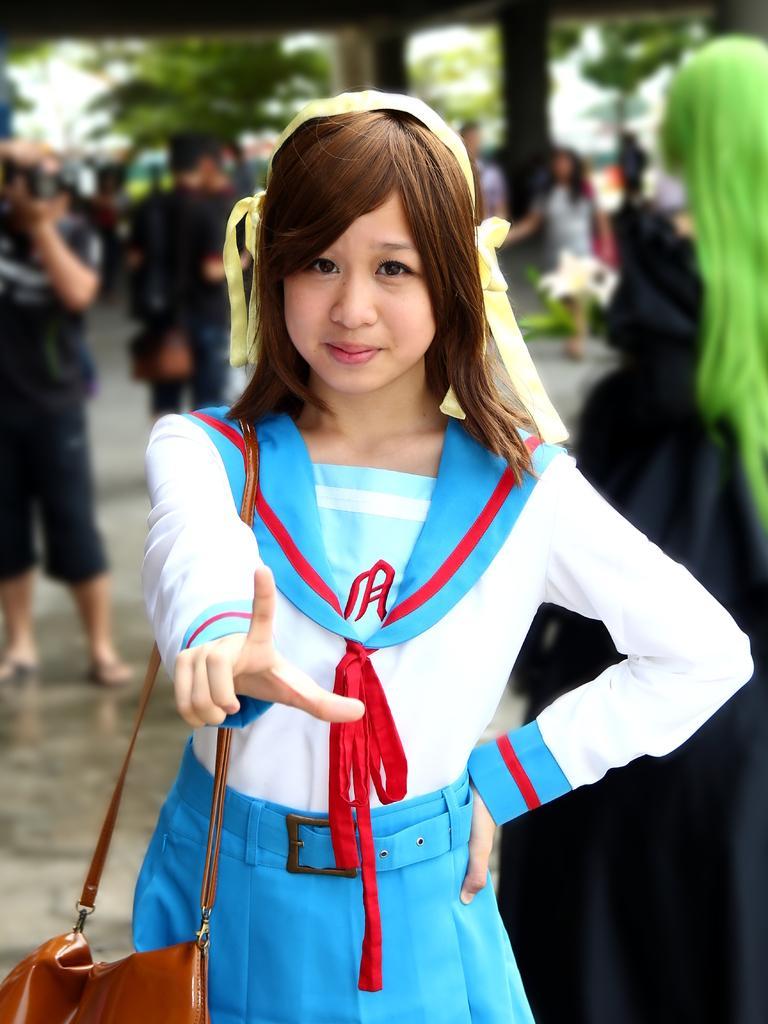Please provide a concise description of this image. A girl wearing a blue and a white dress is holding a bag. Behind her many persons are there. Trees are over there. 